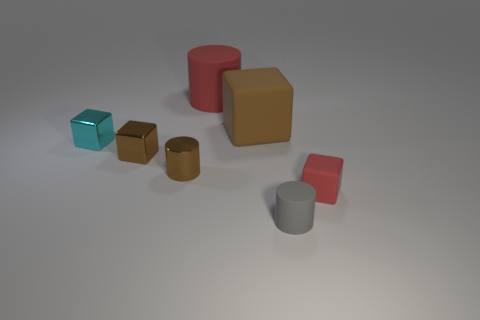Subtract 1 cubes. How many cubes are left? 3 Add 1 tiny brown metallic objects. How many objects exist? 8 Subtract all cubes. How many objects are left? 3 Add 7 big rubber things. How many big rubber things are left? 9 Add 3 big cylinders. How many big cylinders exist? 4 Subtract 0 yellow cylinders. How many objects are left? 7 Subtract all brown shiny blocks. Subtract all small cyan metallic things. How many objects are left? 5 